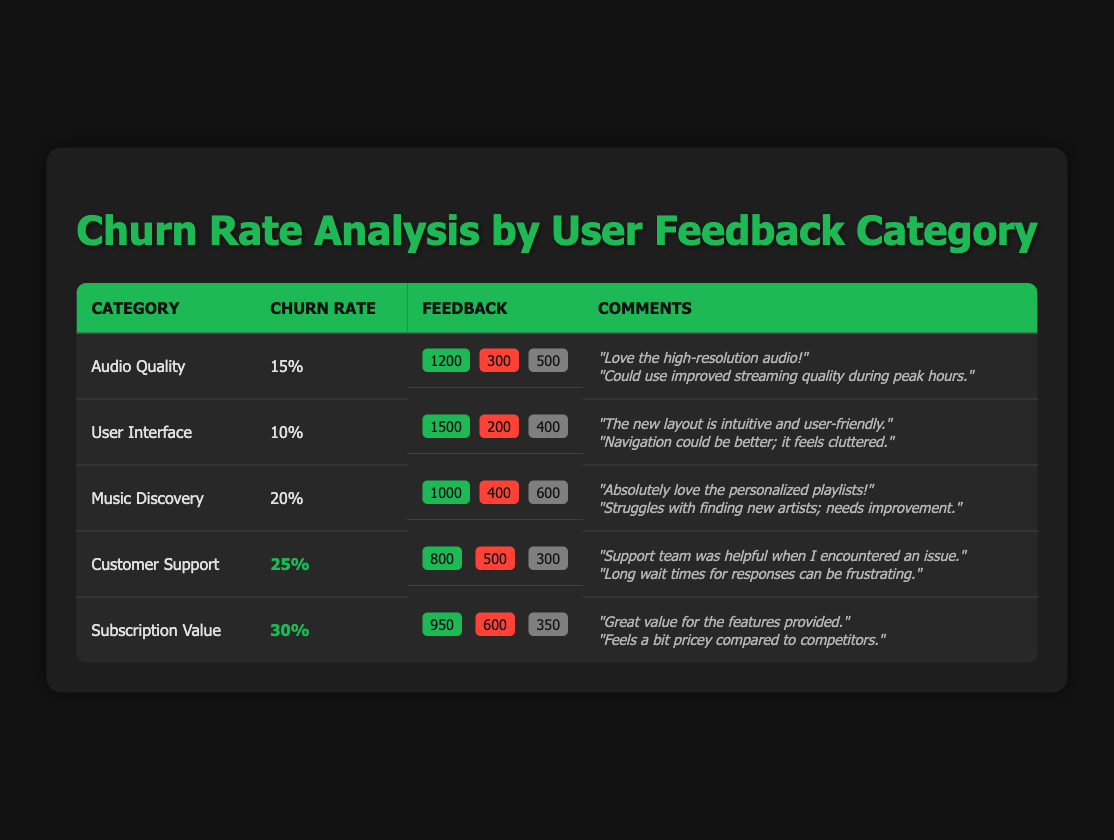What is the churn rate for the "Audio Quality" category? The table shows that the churn rate for the "Audio Quality" category is 15%.
Answer: 15% Which user feedback category has the highest churn rate? The "Subscription Value" category has the highest churn rate at 30%.
Answer: Subscription Value How many positive feedback responses are there for the "User Interface" category? The table indicates that there are 1500 positive feedback responses for the "User Interface" category.
Answer: 1500 What is the total feedback count for "Customer Support" category? To find the total feedback for "Customer Support", sum up the positive (800), negative (500), and neutral (300) counts: 800 + 500 + 300 = 1600.
Answer: 1600 Are there more negative feedback responses for "Music Discovery" than for "Audio Quality"? "Music Discovery" has 400 negative responses while "Audio Quality" has 300, so yes, there are more negative responses for Music Discovery.
Answer: Yes What is the difference in churn rates between "Audio Quality" and "User Interface"? The churn rate for "Audio Quality" is 15%, and for "User Interface" is 10%. The difference is 15% - 10% = 5%.
Answer: 5% Calculate the average churn rate across all categories. The churn rates are 15%, 10%, 20%, 25%, and 30%. The average is (15 + 10 + 20 + 25 + 30) / 5 = 100 / 5 = 20%.
Answer: 20% Is the number of neutral feedback responses for "Subscription Value" category greater than the total number of negative responses for all categories combined? The neutral responses for "Subscription Value" is 350. The total negative responses for all categories is 300 (Audio Quality) + 200 (User Interface) + 400 (Music Discovery) + 500 (Customer Support) + 600 (Subscription Value) = 2000. Therefore, 350 is not greater than 2000.
Answer: No Which category has the smallest number of positive feedback responses? By comparing the positive feedback counts: 1200 (Audio Quality), 1500 (User Interface), 1000 (Music Discovery), 800 (Customer Support), and 950 (Subscription Value), Customer Support has the smallest count with 800.
Answer: Customer Support What percentage of feedback for "Music Discovery" was negative? Negative feedback for "Music Discovery" is 400, total feedback is 1000 (positive) + 400 (negative) + 600 (neutral) = 2000. The percentage is (400 / 2000) * 100 = 20%.
Answer: 20% 